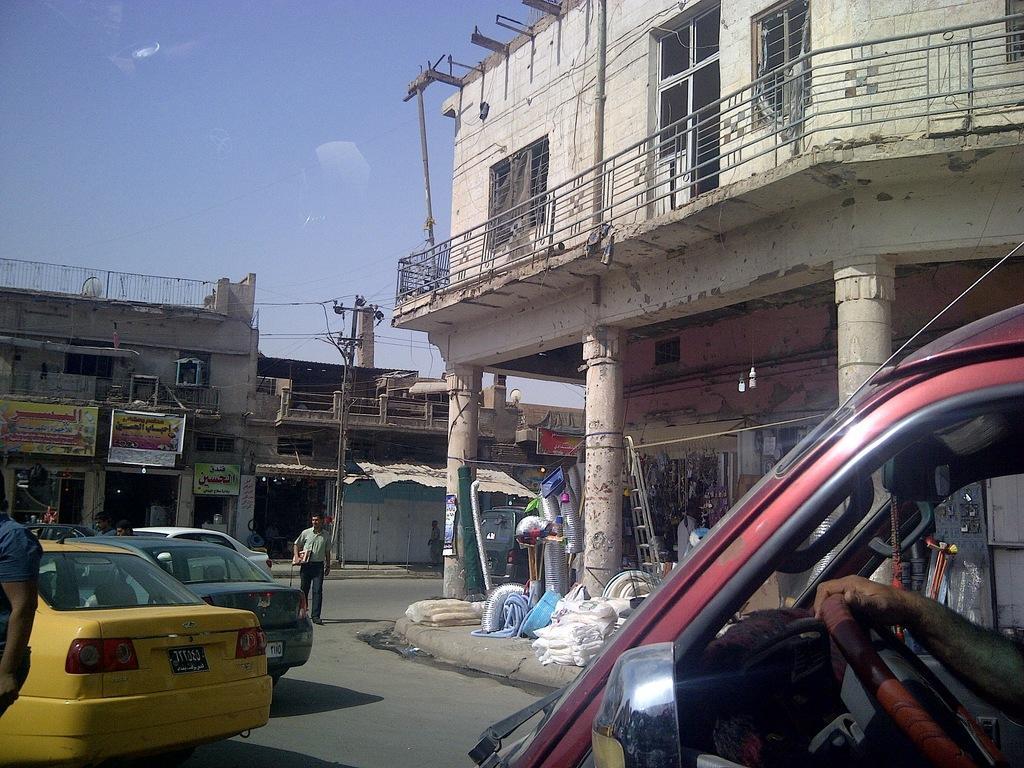Could you give a brief overview of what you see in this image? In the picture I can see buildings, vehicles, people standing on the ground, pillars and some other objects. In the background I can see the sky. 